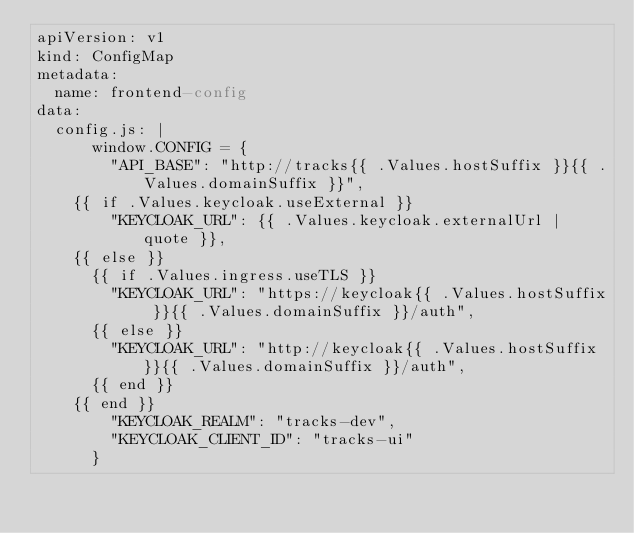<code> <loc_0><loc_0><loc_500><loc_500><_YAML_>apiVersion: v1
kind: ConfigMap
metadata:
  name: frontend-config
data:
  config.js: |
      window.CONFIG = {
        "API_BASE": "http://tracks{{ .Values.hostSuffix }}{{ .Values.domainSuffix }}",
    {{ if .Values.keycloak.useExternal }}
        "KEYCLOAK_URL": {{ .Values.keycloak.externalUrl | quote }},
    {{ else }}
      {{ if .Values.ingress.useTLS }}
        "KEYCLOAK_URL": "https://keycloak{{ .Values.hostSuffix }}{{ .Values.domainSuffix }}/auth",
      {{ else }}
        "KEYCLOAK_URL": "http://keycloak{{ .Values.hostSuffix }}{{ .Values.domainSuffix }}/auth",
      {{ end }}
    {{ end }}
        "KEYCLOAK_REALM": "tracks-dev",
        "KEYCLOAK_CLIENT_ID": "tracks-ui"
      }
</code> 